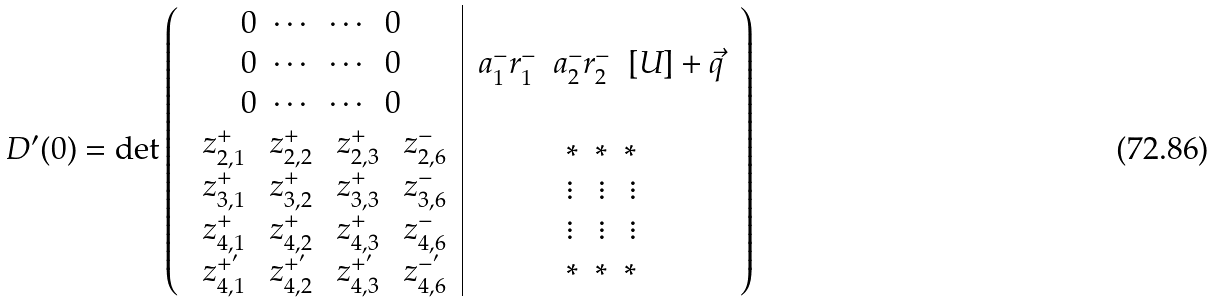Convert formula to latex. <formula><loc_0><loc_0><loc_500><loc_500>D ^ { \prime } ( 0 ) = \det \left ( \begin{array} { c | c } \begin{array} { l c c r } 0 & \cdots & \cdots & 0 \\ 0 & \cdots & \cdots & 0 \\ 0 & \cdots & \cdots & 0 \end{array} & \begin{array} { c c c } a _ { 1 } ^ { - } r _ { 1 } ^ { - } & a _ { 2 } ^ { - } r _ { 2 } ^ { - } & [ U ] + \vec { q } \end{array} \\ \begin{array} { c c c c } \ z _ { 2 , 1 } ^ { + } & \ z _ { 2 , 2 } ^ { + } & \ z _ { 2 , 3 } ^ { + } & \ z _ { 2 , 6 } ^ { - } \\ \ z _ { 3 , 1 } ^ { + } & \ z _ { 3 , 2 } ^ { + } & \ z _ { 3 , 3 } ^ { + } & \ z _ { 3 , 6 } ^ { - } \\ \ z _ { 4 , 1 } ^ { + } & \ z _ { 4 , 2 } ^ { + } & \ z _ { 4 , 3 } ^ { + } & \ z _ { 4 , 6 } ^ { - } \\ \ z _ { 4 , 1 } ^ { + ^ { \prime } } & \ z _ { 4 , 2 } ^ { + ^ { \prime } } & \ z _ { 4 , 3 } ^ { + ^ { \prime } } & \ z _ { 4 , 6 } ^ { - ^ { \prime } } \end{array} & \begin{array} { l c r } * & * & * \\ \vdots & \vdots & \vdots \\ \vdots & \vdots & \vdots \\ * & * & * \end{array} \end{array} \right )</formula> 